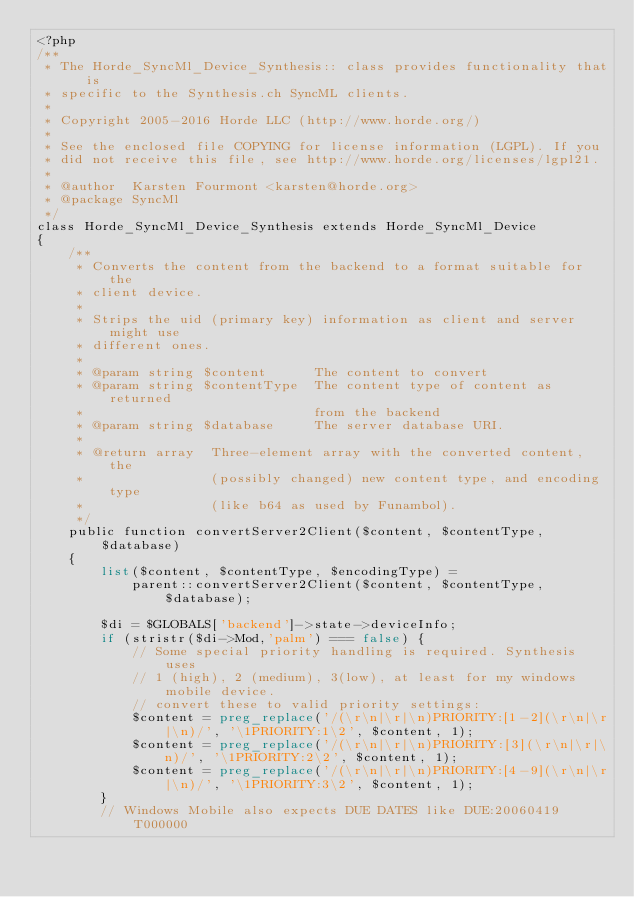Convert code to text. <code><loc_0><loc_0><loc_500><loc_500><_PHP_><?php
/**
 * The Horde_SyncMl_Device_Synthesis:: class provides functionality that is
 * specific to the Synthesis.ch SyncML clients.
 *
 * Copyright 2005-2016 Horde LLC (http://www.horde.org/)
 *
 * See the enclosed file COPYING for license information (LGPL). If you
 * did not receive this file, see http://www.horde.org/licenses/lgpl21.
 *
 * @author  Karsten Fourmont <karsten@horde.org>
 * @package SyncMl
 */
class Horde_SyncMl_Device_Synthesis extends Horde_SyncMl_Device
{
    /**
     * Converts the content from the backend to a format suitable for the
     * client device.
     *
     * Strips the uid (primary key) information as client and server might use
     * different ones.
     *
     * @param string $content      The content to convert
     * @param string $contentType  The content type of content as returned
     *                             from the backend
     * @param string $database     The server database URI.
     *
     * @return array  Three-element array with the converted content, the
     *                (possibly changed) new content type, and encoding type
     *                (like b64 as used by Funambol).
     */
    public function convertServer2Client($content, $contentType, $database)
    {
        list($content, $contentType, $encodingType) =
            parent::convertServer2Client($content, $contentType, $database);

        $di = $GLOBALS['backend']->state->deviceInfo;
        if (stristr($di->Mod,'palm') === false) {
            // Some special priority handling is required. Synthesis uses
            // 1 (high), 2 (medium), 3(low), at least for my windows mobile device.
            // convert these to valid priority settings:
            $content = preg_replace('/(\r\n|\r|\n)PRIORITY:[1-2](\r\n|\r|\n)/', '\1PRIORITY:1\2', $content, 1);
            $content = preg_replace('/(\r\n|\r|\n)PRIORITY:[3](\r\n|\r|\n)/', '\1PRIORITY:2\2', $content, 1);
            $content = preg_replace('/(\r\n|\r|\n)PRIORITY:[4-9](\r\n|\r|\n)/', '\1PRIORITY:3\2', $content, 1);
        }
        // Windows Mobile also expects DUE DATES like DUE:20060419T000000</code> 